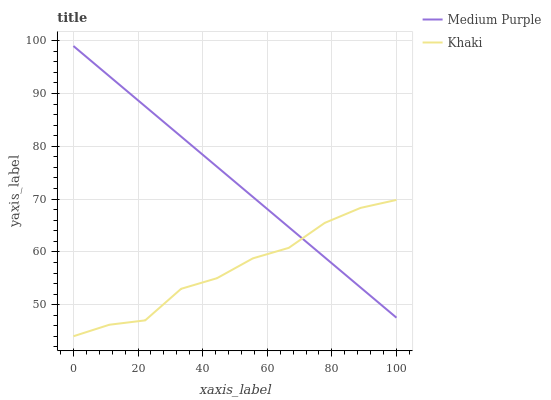Does Khaki have the minimum area under the curve?
Answer yes or no. Yes. Does Medium Purple have the maximum area under the curve?
Answer yes or no. Yes. Does Khaki have the maximum area under the curve?
Answer yes or no. No. Is Medium Purple the smoothest?
Answer yes or no. Yes. Is Khaki the roughest?
Answer yes or no. Yes. Is Khaki the smoothest?
Answer yes or no. No. Does Khaki have the lowest value?
Answer yes or no. Yes. Does Medium Purple have the highest value?
Answer yes or no. Yes. Does Khaki have the highest value?
Answer yes or no. No. Does Khaki intersect Medium Purple?
Answer yes or no. Yes. Is Khaki less than Medium Purple?
Answer yes or no. No. Is Khaki greater than Medium Purple?
Answer yes or no. No. 